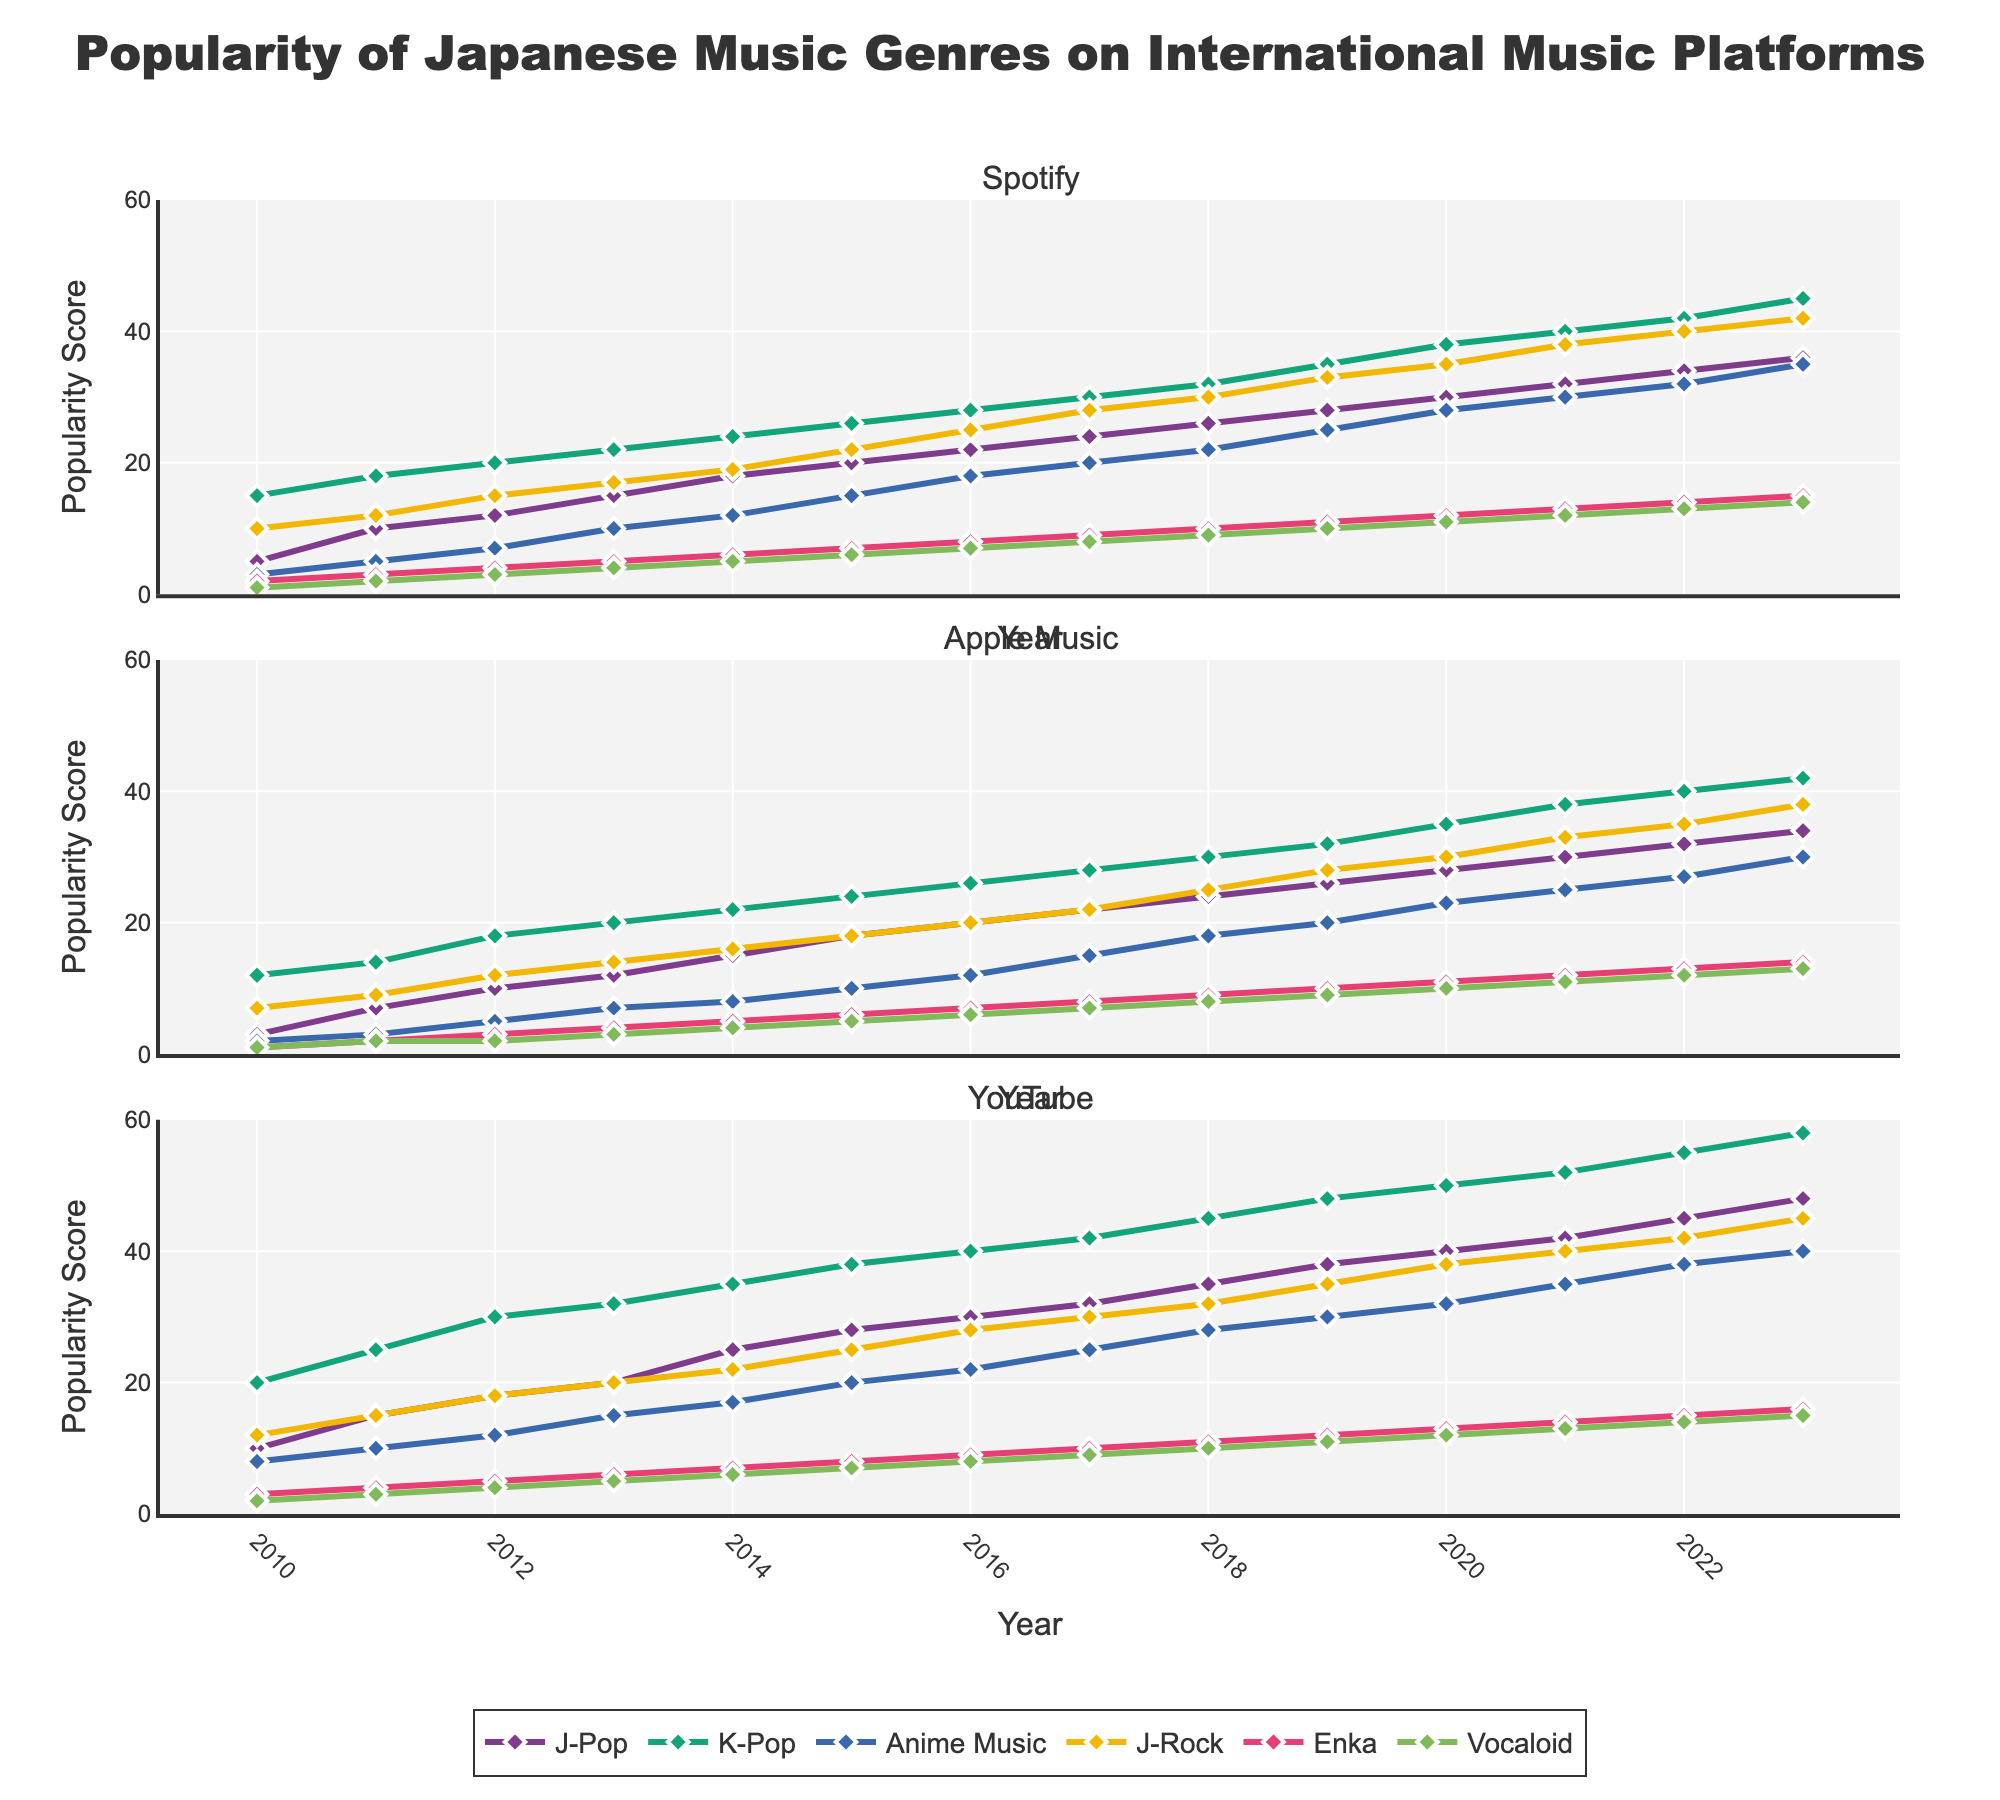What is the title of the figure? The title is at the top of the figure and clearly states the main topic. The title reads "Popularity of Japanese Music Genres on International Music Platforms".
Answer: Popularity of Japanese Music Genres on International Music Platforms How many years of data are displayed in the figure? The x-axis represents the years, starting from 2010 and ending in 2023. Counting these, we find there are 14 years of data.
Answer: 14 What is the trend for Vocaloid music on Spotify from 2010 to 2023? Looking at the line representing Vocaloid music on Spotify, it shows a steady but gradual increase from 1 in 2010 to 14 in 2023.
Answer: Gradual increase Which genre had the highest popularity score on YouTube in 2023? In 2023, the peaks of the lines representing different genres on YouTube show us that K-Pop had the highest score of 58.
Answer: K-Pop Which platform shows the highest popularity score for Anime Music in 2020? By comparing the popularity scores for Anime Music across all platforms in 2020, YouTube shows the highest score of 32.
Answer: YouTube Between J-Pop and J-Rock, which genre saw a larger increase on Apple Music from 2010 to 2023? On Apple Music, J-Pop increased from 3 in 2010 to 34 in 2023, an increase of 31 points. J-Rock increased from 7 in 2010 to 38 in 2023, an increase of 31 points. Thus, both genres saw the same increase.
Answer: Both saw the same increase In which year did Spotify surpass 20 in popularity for at least three different genres? Looking at the lines for different genres on Spotify, in 2015, more than three genres (J-Pop, K-Pop, and Anime Music) surpass the 20 mark.
Answer: 2015 What is the difference in the popularity score of Enka on YouTube between 2010 and 2023? By checking the values for Enka on YouTube in 2010 and 2023, the scores are 3 and 16 respectively. The difference is 16 - 3 = 13.
Answer: 13 Which genre shows the most significant increase in popularity score on all platforms combined from 2010 to 2023? Comparing the increase across all genres on all platforms, K-Pop shows the most significant increase. For YouTube, K-Pop increased from 20 to 58, indicating a strong rise on other platforms as well.
Answer: K-Pop 